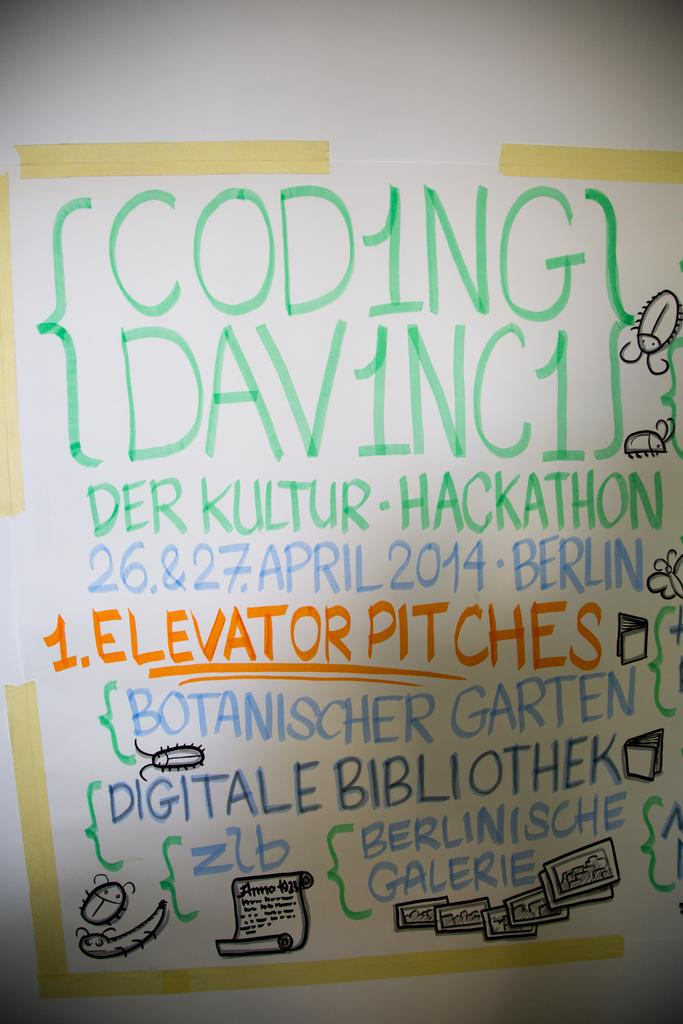<image>
Create a compact narrative representing the image presented. A whiteboard has much information about upcoming events, such as a hackathon. 